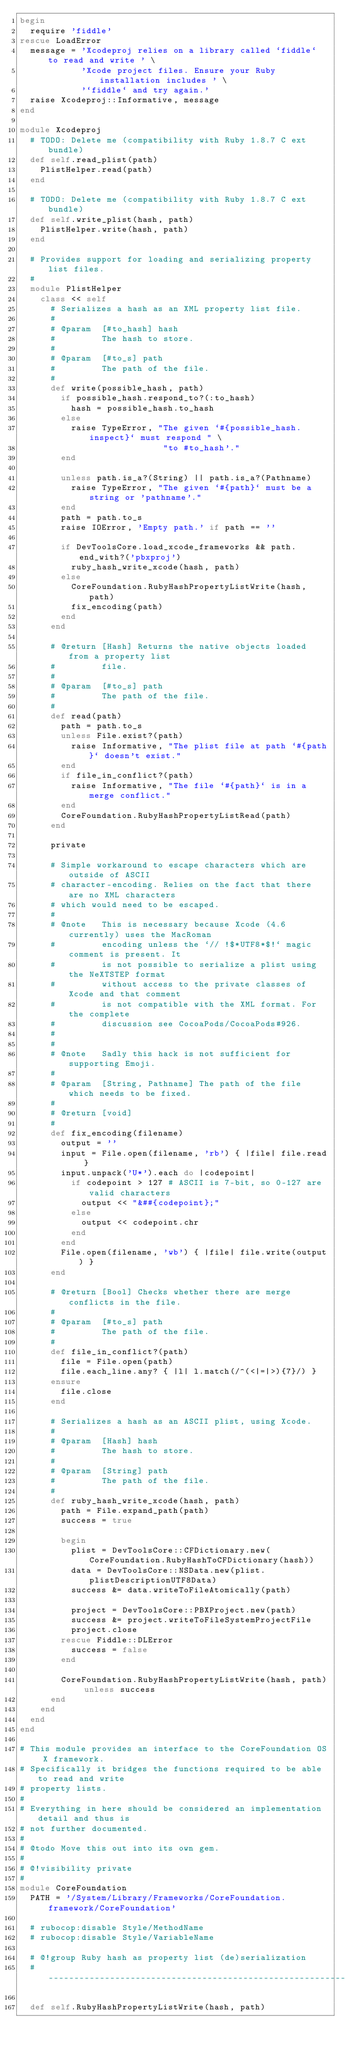Convert code to text. <code><loc_0><loc_0><loc_500><loc_500><_Ruby_>begin
  require 'fiddle'
rescue LoadError
  message = 'Xcodeproj relies on a library called `fiddle` to read and write ' \
            'Xcode project files. Ensure your Ruby installation includes ' \
            '`fiddle` and try again.'
  raise Xcodeproj::Informative, message
end

module Xcodeproj
  # TODO: Delete me (compatibility with Ruby 1.8.7 C ext bundle)
  def self.read_plist(path)
    PlistHelper.read(path)
  end

  # TODO: Delete me (compatibility with Ruby 1.8.7 C ext bundle)
  def self.write_plist(hash, path)
    PlistHelper.write(hash, path)
  end

  # Provides support for loading and serializing property list files.
  #
  module PlistHelper
    class << self
      # Serializes a hash as an XML property list file.
      #
      # @param  [#to_hash] hash
      #         The hash to store.
      #
      # @param  [#to_s] path
      #         The path of the file.
      #
      def write(possible_hash, path)
        if possible_hash.respond_to?(:to_hash)
          hash = possible_hash.to_hash
        else
          raise TypeError, "The given `#{possible_hash.inspect}` must respond " \
                            "to #to_hash'."
        end

        unless path.is_a?(String) || path.is_a?(Pathname)
          raise TypeError, "The given `#{path}` must be a string or 'pathname'."
        end
        path = path.to_s
        raise IOError, 'Empty path.' if path == ''

        if DevToolsCore.load_xcode_frameworks && path.end_with?('pbxproj')
          ruby_hash_write_xcode(hash, path)
        else
          CoreFoundation.RubyHashPropertyListWrite(hash, path)
          fix_encoding(path)
        end
      end

      # @return [Hash] Returns the native objects loaded from a property list
      #         file.
      #
      # @param  [#to_s] path
      #         The path of the file.
      #
      def read(path)
        path = path.to_s
        unless File.exist?(path)
          raise Informative, "The plist file at path `#{path}` doesn't exist."
        end
        if file_in_conflict?(path)
          raise Informative, "The file `#{path}` is in a merge conflict."
        end
        CoreFoundation.RubyHashPropertyListRead(path)
      end

      private

      # Simple workaround to escape characters which are outside of ASCII
      # character-encoding. Relies on the fact that there are no XML characters
      # which would need to be escaped.
      #
      # @note   This is necessary because Xcode (4.6 currently) uses the MacRoman
      #         encoding unless the `// !$*UTF8*$!` magic comment is present. It
      #         is not possible to serialize a plist using the NeXTSTEP format
      #         without access to the private classes of Xcode and that comment
      #         is not compatible with the XML format. For the complete
      #         discussion see CocoaPods/CocoaPods#926.
      #
      #
      # @note   Sadly this hack is not sufficient for supporting Emoji.
      #
      # @param  [String, Pathname] The path of the file which needs to be fixed.
      #
      # @return [void]
      #
      def fix_encoding(filename)
        output = ''
        input = File.open(filename, 'rb') { |file| file.read }
        input.unpack('U*').each do |codepoint|
          if codepoint > 127 # ASCII is 7-bit, so 0-127 are valid characters
            output << "&##{codepoint};"
          else
            output << codepoint.chr
          end
        end
        File.open(filename, 'wb') { |file| file.write(output) }
      end

      # @return [Bool] Checks whether there are merge conflicts in the file.
      #
      # @param  [#to_s] path
      #         The path of the file.
      #
      def file_in_conflict?(path)
        file = File.open(path)
        file.each_line.any? { |l| l.match(/^(<|=|>){7}/) }
      ensure
        file.close
      end

      # Serializes a hash as an ASCII plist, using Xcode.
      #
      # @param  [Hash] hash
      #         The hash to store.
      #
      # @param  [String] path
      #         The path of the file.
      #
      def ruby_hash_write_xcode(hash, path)
        path = File.expand_path(path)
        success = true

        begin
          plist = DevToolsCore::CFDictionary.new(CoreFoundation.RubyHashToCFDictionary(hash))
          data = DevToolsCore::NSData.new(plist.plistDescriptionUTF8Data)
          success &= data.writeToFileAtomically(path)

          project = DevToolsCore::PBXProject.new(path)
          success &= project.writeToFileSystemProjectFile
          project.close
        rescue Fiddle::DLError
          success = false
        end

        CoreFoundation.RubyHashPropertyListWrite(hash, path) unless success
      end
    end
  end
end

# This module provides an interface to the CoreFoundation OS X framework.
# Specifically it bridges the functions required to be able to read and write
# property lists.
#
# Everything in here should be considered an implementation detail and thus is
# not further documented.
#
# @todo Move this out into its own gem.
#
# @!visibility private
#
module CoreFoundation
  PATH = '/System/Library/Frameworks/CoreFoundation.framework/CoreFoundation'

  # rubocop:disable Style/MethodName
  # rubocop:disable Style/VariableName

  # @!group Ruby hash as property list (de)serialization
  #---------------------------------------------------------------------------#

  def self.RubyHashPropertyListWrite(hash, path)</code> 